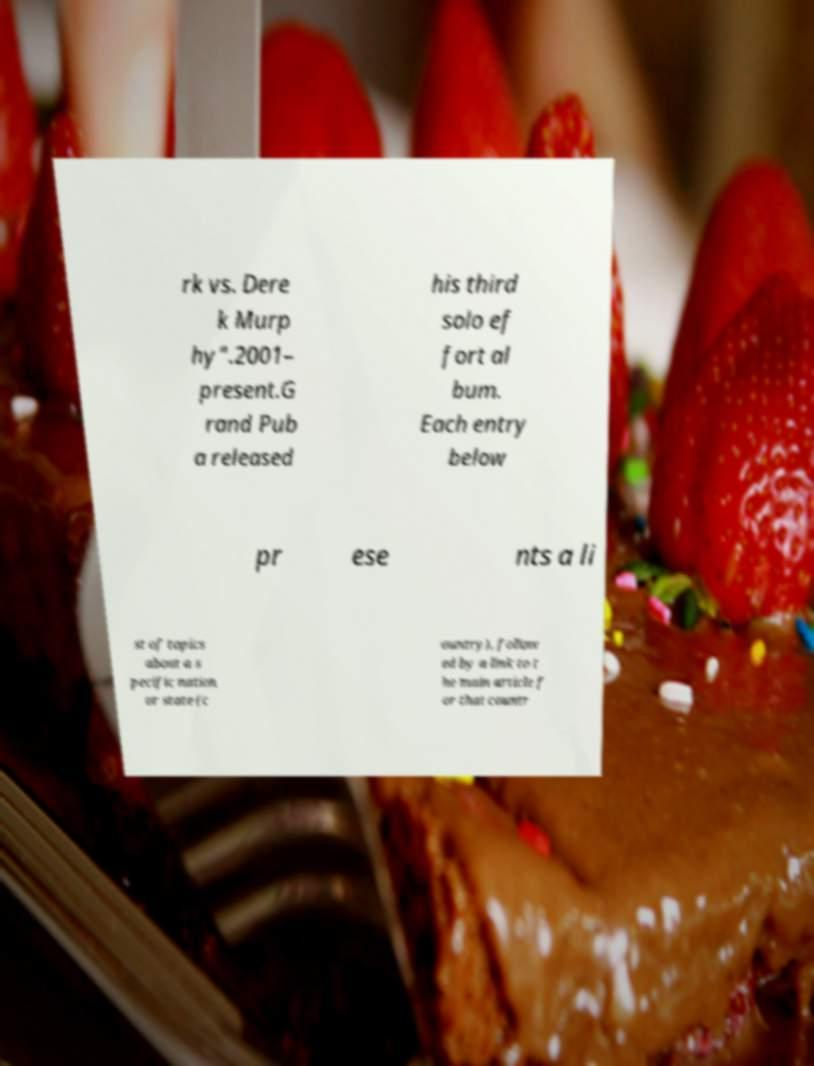What messages or text are displayed in this image? I need them in a readable, typed format. rk vs. Dere k Murp hy".2001– present.G rand Pub a released his third solo ef fort al bum. Each entry below pr ese nts a li st of topics about a s pecific nation or state (c ountry), follow ed by a link to t he main article f or that countr 